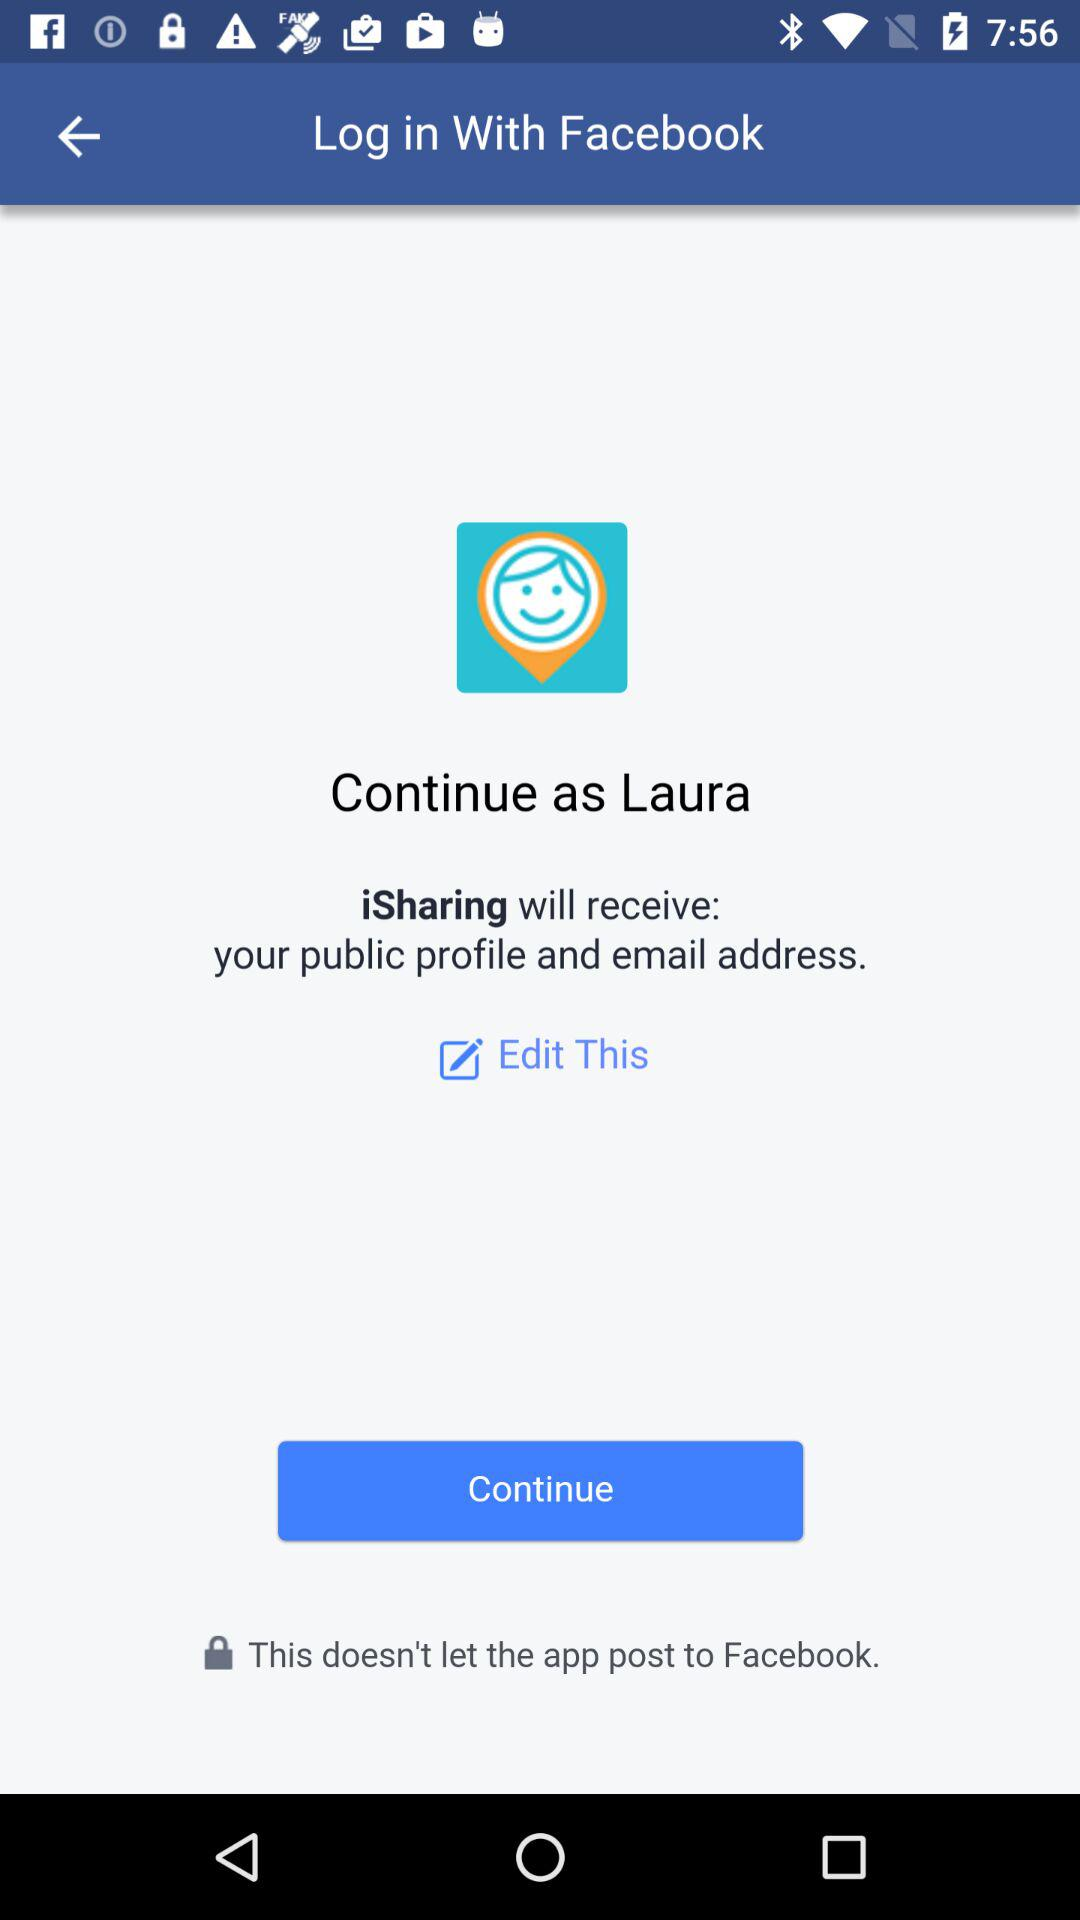What is the name of the user? The name of the user is Laura. 